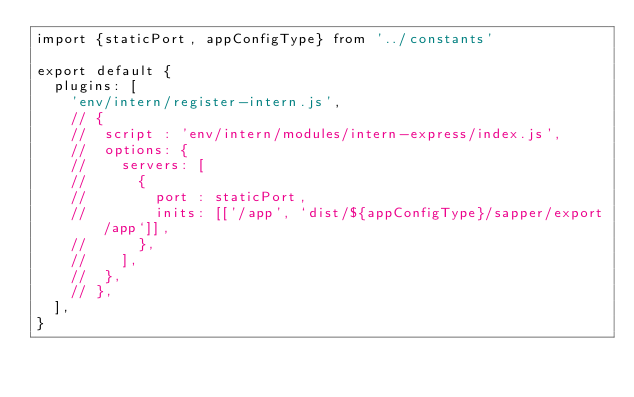<code> <loc_0><loc_0><loc_500><loc_500><_JavaScript_>import {staticPort, appConfigType} from '../constants'

export default {
	plugins: [
		'env/intern/register-intern.js',
		// {
		// 	script : 'env/intern/modules/intern-express/index.js',
		// 	options: {
		// 		servers: [
		// 			{
		// 				port : staticPort,
		// 				inits: [['/app', `dist/${appConfigType}/sapper/export/app`]],
		// 			},
		// 		],
		// 	},
		// },
	],
}
</code> 